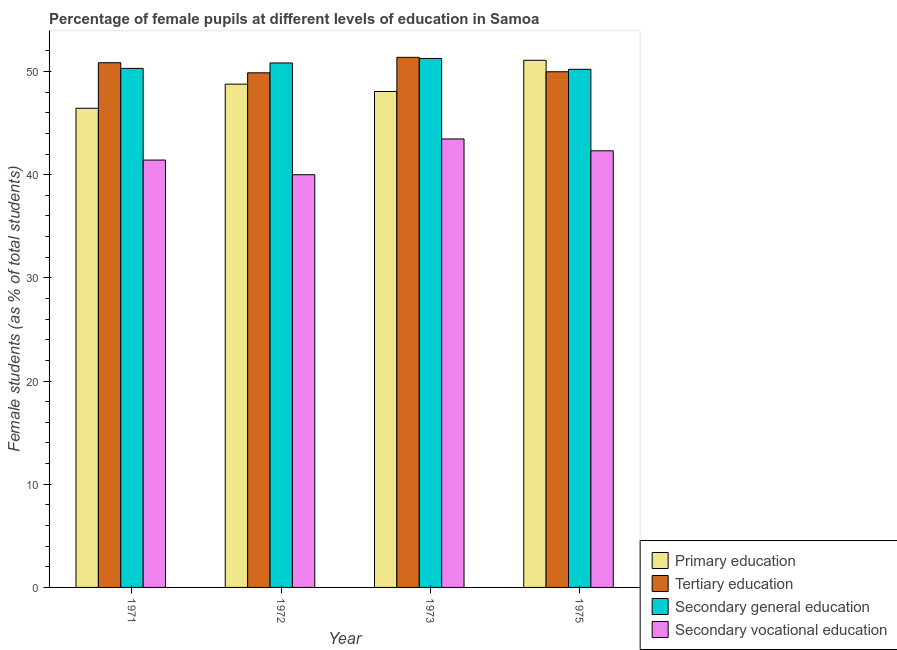How many different coloured bars are there?
Your answer should be very brief. 4. Are the number of bars per tick equal to the number of legend labels?
Offer a very short reply. Yes. How many bars are there on the 1st tick from the left?
Ensure brevity in your answer.  4. In how many cases, is the number of bars for a given year not equal to the number of legend labels?
Provide a succinct answer. 0. What is the percentage of female students in secondary vocational education in 1971?
Give a very brief answer. 41.42. Across all years, what is the maximum percentage of female students in tertiary education?
Offer a terse response. 51.38. Across all years, what is the minimum percentage of female students in tertiary education?
Your answer should be compact. 49.87. What is the total percentage of female students in primary education in the graph?
Offer a terse response. 194.38. What is the difference between the percentage of female students in primary education in 1971 and that in 1975?
Provide a succinct answer. -4.65. What is the difference between the percentage of female students in tertiary education in 1971 and the percentage of female students in secondary vocational education in 1975?
Give a very brief answer. 0.88. What is the average percentage of female students in primary education per year?
Keep it short and to the point. 48.59. In the year 1975, what is the difference between the percentage of female students in primary education and percentage of female students in secondary vocational education?
Your response must be concise. 0. In how many years, is the percentage of female students in primary education greater than 48 %?
Provide a short and direct response. 3. What is the ratio of the percentage of female students in secondary education in 1971 to that in 1973?
Offer a terse response. 0.98. Is the difference between the percentage of female students in primary education in 1972 and 1975 greater than the difference between the percentage of female students in secondary vocational education in 1972 and 1975?
Keep it short and to the point. No. What is the difference between the highest and the second highest percentage of female students in tertiary education?
Your answer should be very brief. 0.52. What is the difference between the highest and the lowest percentage of female students in secondary education?
Keep it short and to the point. 1.05. Is the sum of the percentage of female students in secondary vocational education in 1971 and 1973 greater than the maximum percentage of female students in primary education across all years?
Make the answer very short. Yes. Is it the case that in every year, the sum of the percentage of female students in secondary education and percentage of female students in tertiary education is greater than the sum of percentage of female students in primary education and percentage of female students in secondary vocational education?
Ensure brevity in your answer.  Yes. What does the 1st bar from the left in 1973 represents?
Provide a short and direct response. Primary education. Is it the case that in every year, the sum of the percentage of female students in primary education and percentage of female students in tertiary education is greater than the percentage of female students in secondary education?
Your answer should be compact. Yes. How many bars are there?
Keep it short and to the point. 16. Are all the bars in the graph horizontal?
Keep it short and to the point. No. Does the graph contain any zero values?
Offer a terse response. No. Where does the legend appear in the graph?
Provide a succinct answer. Bottom right. What is the title of the graph?
Provide a short and direct response. Percentage of female pupils at different levels of education in Samoa. What is the label or title of the Y-axis?
Ensure brevity in your answer.  Female students (as % of total students). What is the Female students (as % of total students) of Primary education in 1971?
Provide a short and direct response. 46.44. What is the Female students (as % of total students) of Tertiary education in 1971?
Keep it short and to the point. 50.85. What is the Female students (as % of total students) of Secondary general education in 1971?
Offer a terse response. 50.31. What is the Female students (as % of total students) in Secondary vocational education in 1971?
Provide a short and direct response. 41.42. What is the Female students (as % of total students) in Primary education in 1972?
Offer a very short reply. 48.78. What is the Female students (as % of total students) in Tertiary education in 1972?
Provide a short and direct response. 49.87. What is the Female students (as % of total students) of Secondary general education in 1972?
Offer a very short reply. 50.83. What is the Female students (as % of total students) of Primary education in 1973?
Make the answer very short. 48.07. What is the Female students (as % of total students) in Tertiary education in 1973?
Provide a short and direct response. 51.38. What is the Female students (as % of total students) in Secondary general education in 1973?
Provide a succinct answer. 51.27. What is the Female students (as % of total students) of Secondary vocational education in 1973?
Offer a terse response. 43.47. What is the Female students (as % of total students) in Primary education in 1975?
Offer a very short reply. 51.09. What is the Female students (as % of total students) of Tertiary education in 1975?
Your answer should be very brief. 49.98. What is the Female students (as % of total students) in Secondary general education in 1975?
Your response must be concise. 50.22. What is the Female students (as % of total students) in Secondary vocational education in 1975?
Make the answer very short. 42.32. Across all years, what is the maximum Female students (as % of total students) in Primary education?
Your response must be concise. 51.09. Across all years, what is the maximum Female students (as % of total students) of Tertiary education?
Keep it short and to the point. 51.38. Across all years, what is the maximum Female students (as % of total students) of Secondary general education?
Keep it short and to the point. 51.27. Across all years, what is the maximum Female students (as % of total students) of Secondary vocational education?
Keep it short and to the point. 43.47. Across all years, what is the minimum Female students (as % of total students) in Primary education?
Offer a very short reply. 46.44. Across all years, what is the minimum Female students (as % of total students) of Tertiary education?
Offer a terse response. 49.87. Across all years, what is the minimum Female students (as % of total students) of Secondary general education?
Your answer should be very brief. 50.22. What is the total Female students (as % of total students) in Primary education in the graph?
Offer a very short reply. 194.38. What is the total Female students (as % of total students) of Tertiary education in the graph?
Give a very brief answer. 202.08. What is the total Female students (as % of total students) of Secondary general education in the graph?
Keep it short and to the point. 202.62. What is the total Female students (as % of total students) in Secondary vocational education in the graph?
Keep it short and to the point. 167.2. What is the difference between the Female students (as % of total students) in Primary education in 1971 and that in 1972?
Provide a short and direct response. -2.34. What is the difference between the Female students (as % of total students) of Tertiary education in 1971 and that in 1972?
Provide a short and direct response. 0.98. What is the difference between the Female students (as % of total students) in Secondary general education in 1971 and that in 1972?
Offer a terse response. -0.53. What is the difference between the Female students (as % of total students) in Secondary vocational education in 1971 and that in 1972?
Provide a short and direct response. 1.42. What is the difference between the Female students (as % of total students) of Primary education in 1971 and that in 1973?
Provide a short and direct response. -1.63. What is the difference between the Female students (as % of total students) in Tertiary education in 1971 and that in 1973?
Provide a succinct answer. -0.52. What is the difference between the Female students (as % of total students) in Secondary general education in 1971 and that in 1973?
Your response must be concise. -0.96. What is the difference between the Female students (as % of total students) of Secondary vocational education in 1971 and that in 1973?
Provide a short and direct response. -2.04. What is the difference between the Female students (as % of total students) in Primary education in 1971 and that in 1975?
Keep it short and to the point. -4.65. What is the difference between the Female students (as % of total students) in Tertiary education in 1971 and that in 1975?
Give a very brief answer. 0.88. What is the difference between the Female students (as % of total students) in Secondary general education in 1971 and that in 1975?
Offer a terse response. 0.09. What is the difference between the Female students (as % of total students) of Secondary vocational education in 1971 and that in 1975?
Your answer should be compact. -0.9. What is the difference between the Female students (as % of total students) in Primary education in 1972 and that in 1973?
Offer a very short reply. 0.71. What is the difference between the Female students (as % of total students) of Tertiary education in 1972 and that in 1973?
Keep it short and to the point. -1.5. What is the difference between the Female students (as % of total students) of Secondary general education in 1972 and that in 1973?
Keep it short and to the point. -0.44. What is the difference between the Female students (as % of total students) in Secondary vocational education in 1972 and that in 1973?
Provide a succinct answer. -3.46. What is the difference between the Female students (as % of total students) in Primary education in 1972 and that in 1975?
Provide a succinct answer. -2.31. What is the difference between the Female students (as % of total students) in Tertiary education in 1972 and that in 1975?
Offer a very short reply. -0.1. What is the difference between the Female students (as % of total students) in Secondary general education in 1972 and that in 1975?
Provide a succinct answer. 0.61. What is the difference between the Female students (as % of total students) of Secondary vocational education in 1972 and that in 1975?
Provide a short and direct response. -2.32. What is the difference between the Female students (as % of total students) of Primary education in 1973 and that in 1975?
Your response must be concise. -3.03. What is the difference between the Female students (as % of total students) of Tertiary education in 1973 and that in 1975?
Offer a terse response. 1.4. What is the difference between the Female students (as % of total students) in Secondary general education in 1973 and that in 1975?
Give a very brief answer. 1.05. What is the difference between the Female students (as % of total students) in Secondary vocational education in 1973 and that in 1975?
Ensure brevity in your answer.  1.15. What is the difference between the Female students (as % of total students) of Primary education in 1971 and the Female students (as % of total students) of Tertiary education in 1972?
Your response must be concise. -3.43. What is the difference between the Female students (as % of total students) in Primary education in 1971 and the Female students (as % of total students) in Secondary general education in 1972?
Your response must be concise. -4.39. What is the difference between the Female students (as % of total students) of Primary education in 1971 and the Female students (as % of total students) of Secondary vocational education in 1972?
Make the answer very short. 6.44. What is the difference between the Female students (as % of total students) of Tertiary education in 1971 and the Female students (as % of total students) of Secondary general education in 1972?
Ensure brevity in your answer.  0.02. What is the difference between the Female students (as % of total students) in Tertiary education in 1971 and the Female students (as % of total students) in Secondary vocational education in 1972?
Provide a succinct answer. 10.85. What is the difference between the Female students (as % of total students) of Secondary general education in 1971 and the Female students (as % of total students) of Secondary vocational education in 1972?
Your answer should be very brief. 10.31. What is the difference between the Female students (as % of total students) in Primary education in 1971 and the Female students (as % of total students) in Tertiary education in 1973?
Provide a short and direct response. -4.94. What is the difference between the Female students (as % of total students) in Primary education in 1971 and the Female students (as % of total students) in Secondary general education in 1973?
Offer a very short reply. -4.83. What is the difference between the Female students (as % of total students) in Primary education in 1971 and the Female students (as % of total students) in Secondary vocational education in 1973?
Make the answer very short. 2.98. What is the difference between the Female students (as % of total students) of Tertiary education in 1971 and the Female students (as % of total students) of Secondary general education in 1973?
Give a very brief answer. -0.41. What is the difference between the Female students (as % of total students) in Tertiary education in 1971 and the Female students (as % of total students) in Secondary vocational education in 1973?
Your answer should be very brief. 7.39. What is the difference between the Female students (as % of total students) of Secondary general education in 1971 and the Female students (as % of total students) of Secondary vocational education in 1973?
Ensure brevity in your answer.  6.84. What is the difference between the Female students (as % of total students) in Primary education in 1971 and the Female students (as % of total students) in Tertiary education in 1975?
Give a very brief answer. -3.54. What is the difference between the Female students (as % of total students) in Primary education in 1971 and the Female students (as % of total students) in Secondary general education in 1975?
Ensure brevity in your answer.  -3.78. What is the difference between the Female students (as % of total students) in Primary education in 1971 and the Female students (as % of total students) in Secondary vocational education in 1975?
Provide a succinct answer. 4.12. What is the difference between the Female students (as % of total students) of Tertiary education in 1971 and the Female students (as % of total students) of Secondary general education in 1975?
Give a very brief answer. 0.64. What is the difference between the Female students (as % of total students) of Tertiary education in 1971 and the Female students (as % of total students) of Secondary vocational education in 1975?
Your answer should be very brief. 8.53. What is the difference between the Female students (as % of total students) in Secondary general education in 1971 and the Female students (as % of total students) in Secondary vocational education in 1975?
Keep it short and to the point. 7.99. What is the difference between the Female students (as % of total students) of Primary education in 1972 and the Female students (as % of total students) of Tertiary education in 1973?
Provide a short and direct response. -2.6. What is the difference between the Female students (as % of total students) in Primary education in 1972 and the Female students (as % of total students) in Secondary general education in 1973?
Offer a very short reply. -2.49. What is the difference between the Female students (as % of total students) in Primary education in 1972 and the Female students (as % of total students) in Secondary vocational education in 1973?
Offer a terse response. 5.31. What is the difference between the Female students (as % of total students) of Tertiary education in 1972 and the Female students (as % of total students) of Secondary general education in 1973?
Ensure brevity in your answer.  -1.39. What is the difference between the Female students (as % of total students) of Tertiary education in 1972 and the Female students (as % of total students) of Secondary vocational education in 1973?
Your response must be concise. 6.41. What is the difference between the Female students (as % of total students) of Secondary general education in 1972 and the Female students (as % of total students) of Secondary vocational education in 1973?
Provide a short and direct response. 7.37. What is the difference between the Female students (as % of total students) of Primary education in 1972 and the Female students (as % of total students) of Tertiary education in 1975?
Ensure brevity in your answer.  -1.2. What is the difference between the Female students (as % of total students) in Primary education in 1972 and the Female students (as % of total students) in Secondary general education in 1975?
Your response must be concise. -1.44. What is the difference between the Female students (as % of total students) in Primary education in 1972 and the Female students (as % of total students) in Secondary vocational education in 1975?
Keep it short and to the point. 6.46. What is the difference between the Female students (as % of total students) of Tertiary education in 1972 and the Female students (as % of total students) of Secondary general education in 1975?
Give a very brief answer. -0.34. What is the difference between the Female students (as % of total students) of Tertiary education in 1972 and the Female students (as % of total students) of Secondary vocational education in 1975?
Provide a short and direct response. 7.56. What is the difference between the Female students (as % of total students) of Secondary general education in 1972 and the Female students (as % of total students) of Secondary vocational education in 1975?
Your answer should be compact. 8.51. What is the difference between the Female students (as % of total students) of Primary education in 1973 and the Female students (as % of total students) of Tertiary education in 1975?
Provide a succinct answer. -1.91. What is the difference between the Female students (as % of total students) in Primary education in 1973 and the Female students (as % of total students) in Secondary general education in 1975?
Provide a succinct answer. -2.15. What is the difference between the Female students (as % of total students) of Primary education in 1973 and the Female students (as % of total students) of Secondary vocational education in 1975?
Offer a very short reply. 5.75. What is the difference between the Female students (as % of total students) of Tertiary education in 1973 and the Female students (as % of total students) of Secondary general education in 1975?
Give a very brief answer. 1.16. What is the difference between the Female students (as % of total students) in Tertiary education in 1973 and the Female students (as % of total students) in Secondary vocational education in 1975?
Offer a very short reply. 9.06. What is the difference between the Female students (as % of total students) in Secondary general education in 1973 and the Female students (as % of total students) in Secondary vocational education in 1975?
Provide a succinct answer. 8.95. What is the average Female students (as % of total students) in Primary education per year?
Provide a short and direct response. 48.59. What is the average Female students (as % of total students) in Tertiary education per year?
Keep it short and to the point. 50.52. What is the average Female students (as % of total students) in Secondary general education per year?
Offer a very short reply. 50.66. What is the average Female students (as % of total students) of Secondary vocational education per year?
Make the answer very short. 41.8. In the year 1971, what is the difference between the Female students (as % of total students) of Primary education and Female students (as % of total students) of Tertiary education?
Keep it short and to the point. -4.41. In the year 1971, what is the difference between the Female students (as % of total students) in Primary education and Female students (as % of total students) in Secondary general education?
Give a very brief answer. -3.86. In the year 1971, what is the difference between the Female students (as % of total students) of Primary education and Female students (as % of total students) of Secondary vocational education?
Give a very brief answer. 5.02. In the year 1971, what is the difference between the Female students (as % of total students) in Tertiary education and Female students (as % of total students) in Secondary general education?
Your answer should be very brief. 0.55. In the year 1971, what is the difference between the Female students (as % of total students) of Tertiary education and Female students (as % of total students) of Secondary vocational education?
Give a very brief answer. 9.43. In the year 1971, what is the difference between the Female students (as % of total students) in Secondary general education and Female students (as % of total students) in Secondary vocational education?
Keep it short and to the point. 8.88. In the year 1972, what is the difference between the Female students (as % of total students) of Primary education and Female students (as % of total students) of Tertiary education?
Ensure brevity in your answer.  -1.1. In the year 1972, what is the difference between the Female students (as % of total students) in Primary education and Female students (as % of total students) in Secondary general education?
Your response must be concise. -2.05. In the year 1972, what is the difference between the Female students (as % of total students) in Primary education and Female students (as % of total students) in Secondary vocational education?
Make the answer very short. 8.78. In the year 1972, what is the difference between the Female students (as % of total students) in Tertiary education and Female students (as % of total students) in Secondary general education?
Ensure brevity in your answer.  -0.96. In the year 1972, what is the difference between the Female students (as % of total students) in Tertiary education and Female students (as % of total students) in Secondary vocational education?
Your response must be concise. 9.87. In the year 1972, what is the difference between the Female students (as % of total students) of Secondary general education and Female students (as % of total students) of Secondary vocational education?
Your response must be concise. 10.83. In the year 1973, what is the difference between the Female students (as % of total students) of Primary education and Female students (as % of total students) of Tertiary education?
Offer a terse response. -3.31. In the year 1973, what is the difference between the Female students (as % of total students) of Primary education and Female students (as % of total students) of Secondary general education?
Provide a short and direct response. -3.2. In the year 1973, what is the difference between the Female students (as % of total students) in Primary education and Female students (as % of total students) in Secondary vocational education?
Provide a succinct answer. 4.6. In the year 1973, what is the difference between the Female students (as % of total students) of Tertiary education and Female students (as % of total students) of Secondary general education?
Your answer should be very brief. 0.11. In the year 1973, what is the difference between the Female students (as % of total students) in Tertiary education and Female students (as % of total students) in Secondary vocational education?
Make the answer very short. 7.91. In the year 1973, what is the difference between the Female students (as % of total students) in Secondary general education and Female students (as % of total students) in Secondary vocational education?
Offer a terse response. 7.8. In the year 1975, what is the difference between the Female students (as % of total students) in Primary education and Female students (as % of total students) in Tertiary education?
Your response must be concise. 1.11. In the year 1975, what is the difference between the Female students (as % of total students) in Primary education and Female students (as % of total students) in Secondary general education?
Keep it short and to the point. 0.87. In the year 1975, what is the difference between the Female students (as % of total students) of Primary education and Female students (as % of total students) of Secondary vocational education?
Provide a succinct answer. 8.77. In the year 1975, what is the difference between the Female students (as % of total students) of Tertiary education and Female students (as % of total students) of Secondary general education?
Keep it short and to the point. -0.24. In the year 1975, what is the difference between the Female students (as % of total students) of Tertiary education and Female students (as % of total students) of Secondary vocational education?
Provide a short and direct response. 7.66. In the year 1975, what is the difference between the Female students (as % of total students) of Secondary general education and Female students (as % of total students) of Secondary vocational education?
Offer a terse response. 7.9. What is the ratio of the Female students (as % of total students) of Primary education in 1971 to that in 1972?
Keep it short and to the point. 0.95. What is the ratio of the Female students (as % of total students) of Tertiary education in 1971 to that in 1972?
Offer a very short reply. 1.02. What is the ratio of the Female students (as % of total students) in Secondary general education in 1971 to that in 1972?
Provide a succinct answer. 0.99. What is the ratio of the Female students (as % of total students) in Secondary vocational education in 1971 to that in 1972?
Provide a succinct answer. 1.04. What is the ratio of the Female students (as % of total students) of Primary education in 1971 to that in 1973?
Offer a terse response. 0.97. What is the ratio of the Female students (as % of total students) in Secondary general education in 1971 to that in 1973?
Provide a short and direct response. 0.98. What is the ratio of the Female students (as % of total students) in Secondary vocational education in 1971 to that in 1973?
Provide a short and direct response. 0.95. What is the ratio of the Female students (as % of total students) of Primary education in 1971 to that in 1975?
Make the answer very short. 0.91. What is the ratio of the Female students (as % of total students) of Tertiary education in 1971 to that in 1975?
Keep it short and to the point. 1.02. What is the ratio of the Female students (as % of total students) of Secondary vocational education in 1971 to that in 1975?
Make the answer very short. 0.98. What is the ratio of the Female students (as % of total students) in Primary education in 1972 to that in 1973?
Your answer should be very brief. 1.01. What is the ratio of the Female students (as % of total students) in Tertiary education in 1972 to that in 1973?
Provide a succinct answer. 0.97. What is the ratio of the Female students (as % of total students) of Secondary general education in 1972 to that in 1973?
Ensure brevity in your answer.  0.99. What is the ratio of the Female students (as % of total students) of Secondary vocational education in 1972 to that in 1973?
Make the answer very short. 0.92. What is the ratio of the Female students (as % of total students) in Primary education in 1972 to that in 1975?
Give a very brief answer. 0.95. What is the ratio of the Female students (as % of total students) in Secondary general education in 1972 to that in 1975?
Make the answer very short. 1.01. What is the ratio of the Female students (as % of total students) of Secondary vocational education in 1972 to that in 1975?
Offer a terse response. 0.95. What is the ratio of the Female students (as % of total students) of Primary education in 1973 to that in 1975?
Keep it short and to the point. 0.94. What is the ratio of the Female students (as % of total students) in Tertiary education in 1973 to that in 1975?
Provide a short and direct response. 1.03. What is the ratio of the Female students (as % of total students) of Secondary general education in 1973 to that in 1975?
Give a very brief answer. 1.02. What is the ratio of the Female students (as % of total students) in Secondary vocational education in 1973 to that in 1975?
Provide a succinct answer. 1.03. What is the difference between the highest and the second highest Female students (as % of total students) of Primary education?
Provide a short and direct response. 2.31. What is the difference between the highest and the second highest Female students (as % of total students) in Tertiary education?
Make the answer very short. 0.52. What is the difference between the highest and the second highest Female students (as % of total students) of Secondary general education?
Your answer should be compact. 0.44. What is the difference between the highest and the second highest Female students (as % of total students) of Secondary vocational education?
Offer a terse response. 1.15. What is the difference between the highest and the lowest Female students (as % of total students) of Primary education?
Give a very brief answer. 4.65. What is the difference between the highest and the lowest Female students (as % of total students) in Tertiary education?
Provide a succinct answer. 1.5. What is the difference between the highest and the lowest Female students (as % of total students) in Secondary general education?
Offer a very short reply. 1.05. What is the difference between the highest and the lowest Female students (as % of total students) in Secondary vocational education?
Your answer should be very brief. 3.46. 